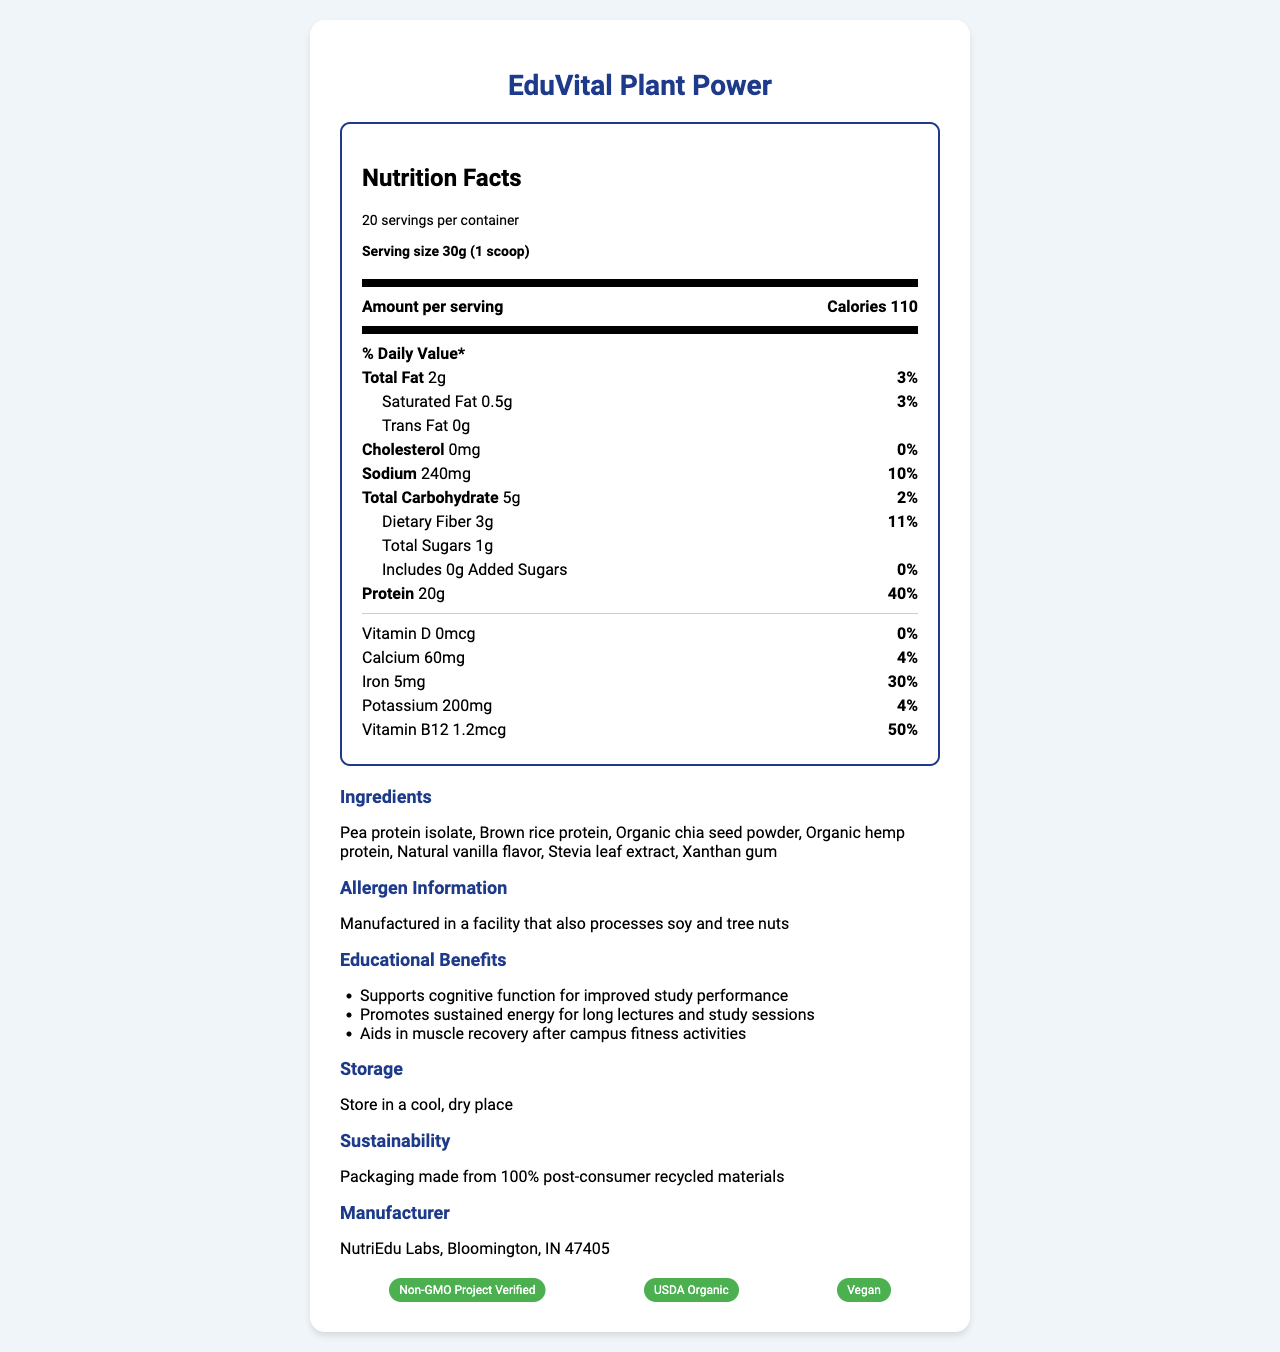what is the serving size of EduVital Plant Power? The serving size is mentioned at the top of the Nutrition Facts label as "Serving size 30g (1 scoop)."
Answer: 30g (1 scoop) how many servings are in one container? The number of servings per container is specified in the label header as "20 servings per container."
Answer: 20 servings what is the total fat content per serving? The total fat per serving is listed as "Total Fat 2g" in the nutrient section.
Answer: 2g how much protein does one serving provide? The protein content per serving is mentioned in the nutrient section as "Protein 20g."
Answer: 20g what is the amount of dietary fiber per serving? The amount of dietary fiber per serving is listed as "Dietary Fiber 3g."
Answer: 3g what is the percentage daily value of iron per serving? The daily value for iron is provided as "Iron 30%" in the document.
Answer: 30% how many calories are in one serving? The calorie count per serving is clearly stated at the top of the label in the "Amount per serving" section as "Calories 110."
Answer: 110 calories which vitamin has the highest daily value percentage in EduVital Plant Power? A. Vitamin D B. Calcium C. Iron D. Vitamin B12 Vitamin B12 has the highest daily value percentage at 50%, as stated in the nutrient section.
Answer: D which of the following is NOT an ingredient in EduVital Plant Power? A. Pea protein isolate B. Brown rice protein C. Organic chia seed powder D. Whey protein Whey protein is not listed in the ingredients section; all other options are.
Answer: D is this product certified as Vegan? The document lists "Vegan" as one of its certifications in the certifications section.
Answer: Yes what are the educational benefits of this product? The educational benefits are listed in the section specifically titled "Educational Benefits," with details like supporting cognitive function, promoting sustained energy, and aiding muscle recovery.
Answer: It supports cognitive function, promotes sustained energy, and aids in muscle recovery. summarize the key information provided in the document about EduVital Plant Power. The document provides detailed nutritional information, ingredients, allergen info, educational benefits, storage instructions, sustainability info, and manufacturer details.
Answer: EduVital Plant Power is a plant-based protein powder with a serving size of 30g, providing 20g of protein per serving. The product is manufactured by NutriEdu Labs and contains various plant-based ingredients like pea protein isolate and organic chia seed powder. The product offers educational benefits such as supporting cognitive function and muscle recovery. It has certifications like Non-GMO, USDA Organic, and Vegan, and is packaged sustainably. what is the storage recommendation for EduVital Plant Power? The storage recommendation is given in the "Storage" section of the document.
Answer: Store in a cool, dry place what other products does NutriEdu Labs manufacture? The document only mentions EduVital Plant Power and does not provide information about other products manufactured by NutriEdu Labs.
Answer: I don't know 